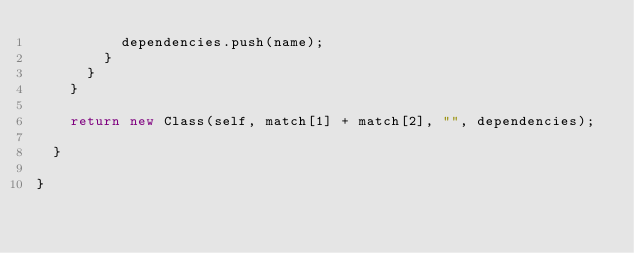Convert code to text. <code><loc_0><loc_0><loc_500><loc_500><_TypeScript_>          dependencies.push(name);
        }
      }
    }

    return new Class(self, match[1] + match[2], "", dependencies);

  }

}
</code> 